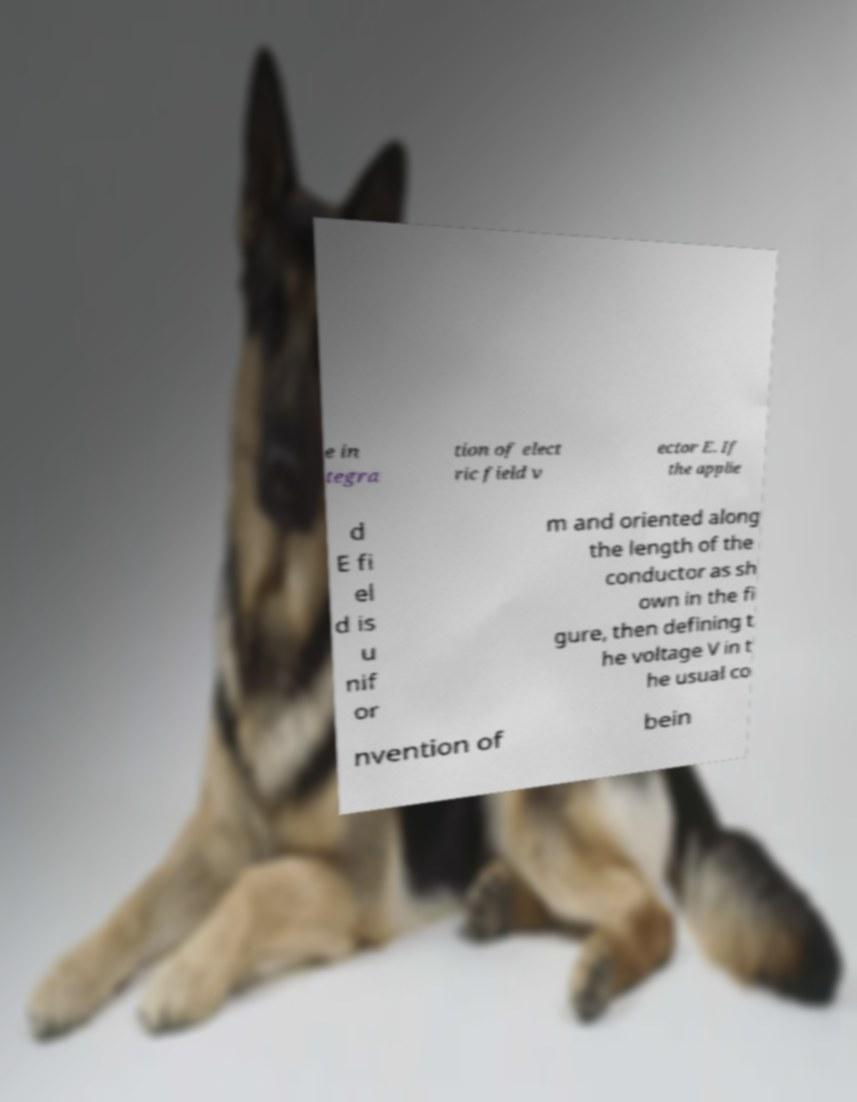Could you assist in decoding the text presented in this image and type it out clearly? e in tegra tion of elect ric field v ector E. If the applie d E fi el d is u nif or m and oriented along the length of the conductor as sh own in the fi gure, then defining t he voltage V in t he usual co nvention of bein 